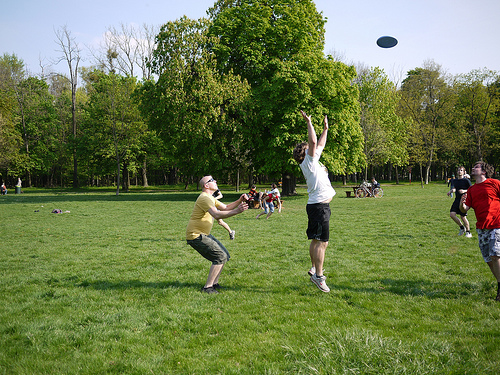Which side is the frisbee on? The frisbee is on the right side of the image. 